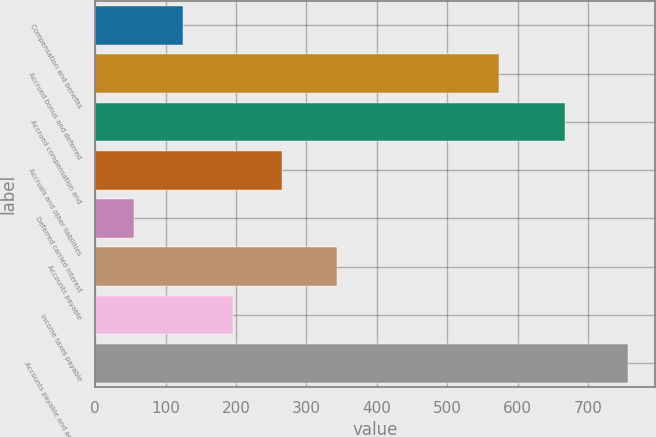Convert chart. <chart><loc_0><loc_0><loc_500><loc_500><bar_chart><fcel>Compensation and benefits<fcel>Accrued bonus and deferred<fcel>Accrued compensation and<fcel>Accruals and other liabilities<fcel>Deferred carried interest<fcel>Accounts payable<fcel>Income taxes payable<fcel>Accounts payable and accrued<nl><fcel>125.05<fcel>572.9<fcel>667.3<fcel>265.55<fcel>54.8<fcel>343.5<fcel>195.3<fcel>757.3<nl></chart> 